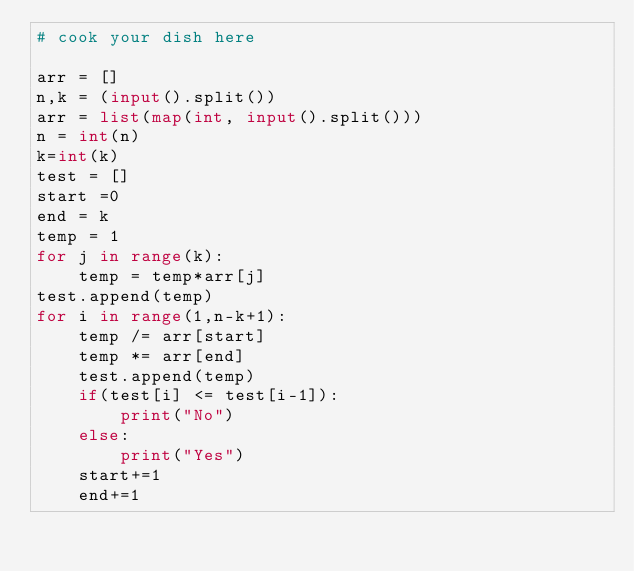<code> <loc_0><loc_0><loc_500><loc_500><_Python_># cook your dish here

arr = []
n,k = (input().split())
arr = list(map(int, input().split()))
n = int(n)
k=int(k)
test = []
start =0
end = k
temp = 1
for j in range(k):
    temp = temp*arr[j]
test.append(temp)
for i in range(1,n-k+1):
    temp /= arr[start]
    temp *= arr[end]
    test.append(temp)
    if(test[i] <= test[i-1]):
        print("No")
    else:
        print("Yes")
    start+=1
    end+=1
</code> 